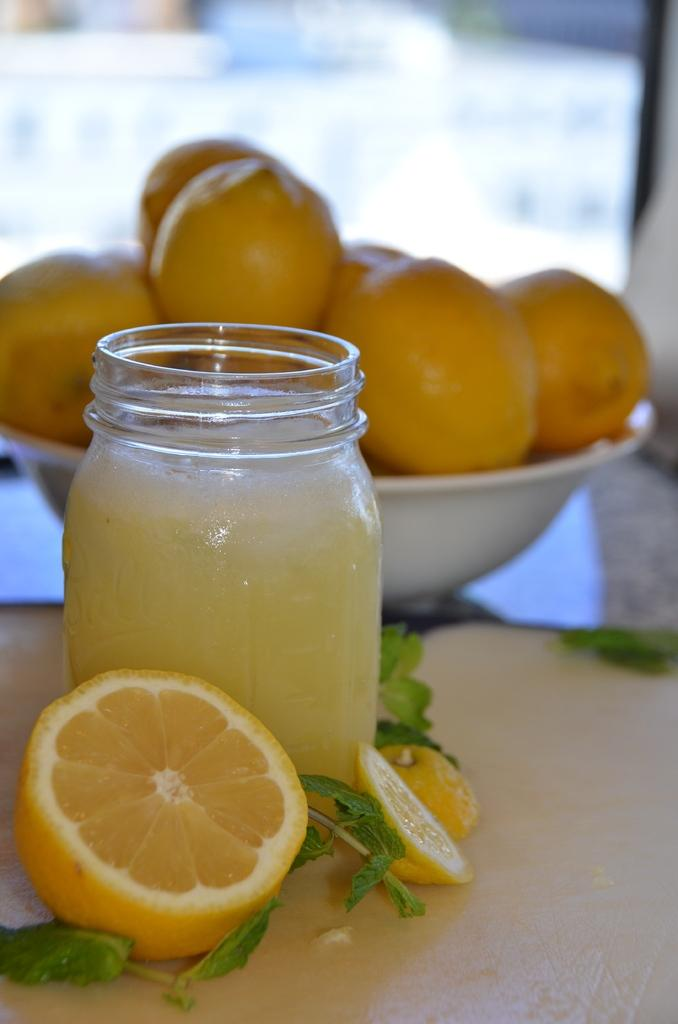What object can be seen in the image that is typically used for holding liquids? There is a bottle in the image. What type of food item is visible in the image? There is a food item in the image. What is the arrangement of fruits in the image? There is a group of fruits in a bowl in the image. How would you describe the background of the image? The background of the image is blurred. What type of caption is written on the bottle in the image? There is no caption written on the bottle in the image. How does the acoustics of the room affect the sound of the fruits in the bowl? There is no information about the acoustics of the room or the sound of the fruits in the image. 